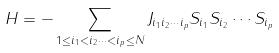Convert formula to latex. <formula><loc_0><loc_0><loc_500><loc_500>H = - \sum _ { 1 \leq i _ { 1 } < i _ { 2 } \cdots < i _ { p } \leq N } J _ { i _ { 1 } i _ { 2 } \cdots i _ { p } } S _ { i _ { 1 } } S _ { i _ { 2 } } \cdots S _ { i _ { p } }</formula> 